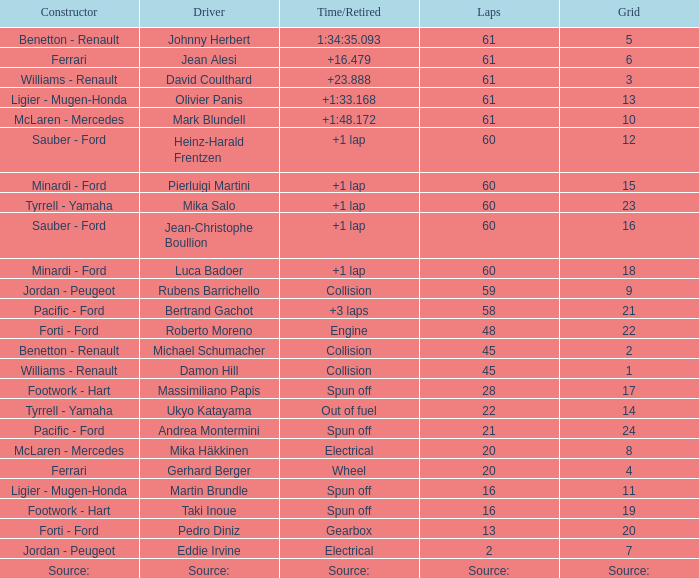How many laps does roberto moreno have? 48.0. 